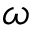<formula> <loc_0><loc_0><loc_500><loc_500>\omega</formula> 